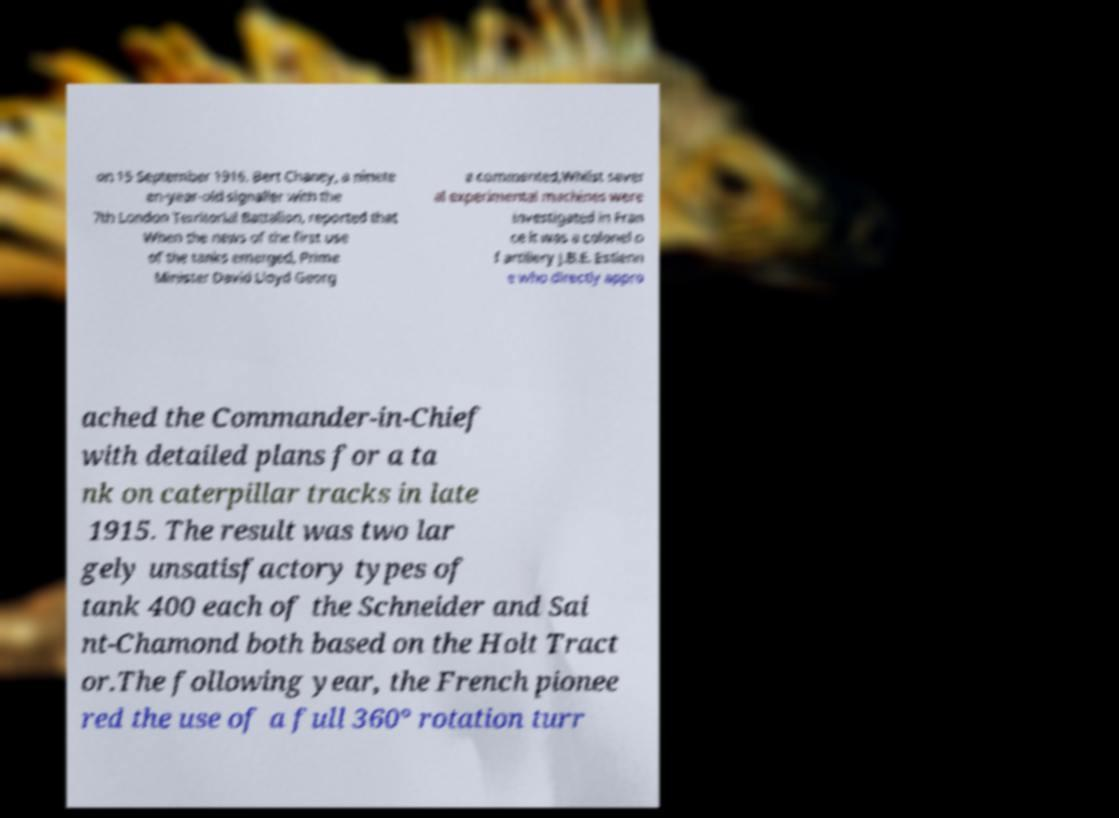Please identify and transcribe the text found in this image. on 15 September 1916. Bert Chaney, a ninete en-year-old signaller with the 7th London Territorial Battalion, reported that When the news of the first use of the tanks emerged, Prime Minister David Lloyd Georg e commented,Whilst sever al experimental machines were investigated in Fran ce it was a colonel o f artillery J.B.E. Estienn e who directly appro ached the Commander-in-Chief with detailed plans for a ta nk on caterpillar tracks in late 1915. The result was two lar gely unsatisfactory types of tank 400 each of the Schneider and Sai nt-Chamond both based on the Holt Tract or.The following year, the French pionee red the use of a full 360° rotation turr 